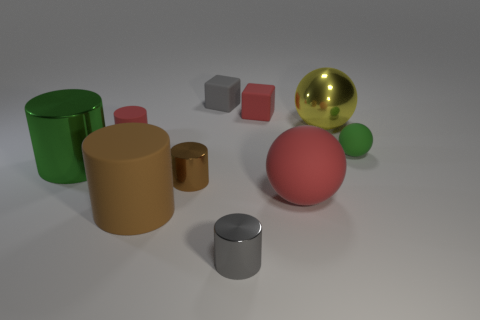Subtract 1 cylinders. How many cylinders are left? 4 Subtract all red cylinders. How many cylinders are left? 4 Subtract all large green cylinders. How many cylinders are left? 4 Subtract all purple cylinders. Subtract all cyan blocks. How many cylinders are left? 5 Subtract all blocks. How many objects are left? 8 Add 1 rubber things. How many rubber things are left? 7 Add 2 big yellow metal spheres. How many big yellow metal spheres exist? 3 Subtract 0 yellow cylinders. How many objects are left? 10 Subtract all metallic spheres. Subtract all large yellow matte spheres. How many objects are left? 9 